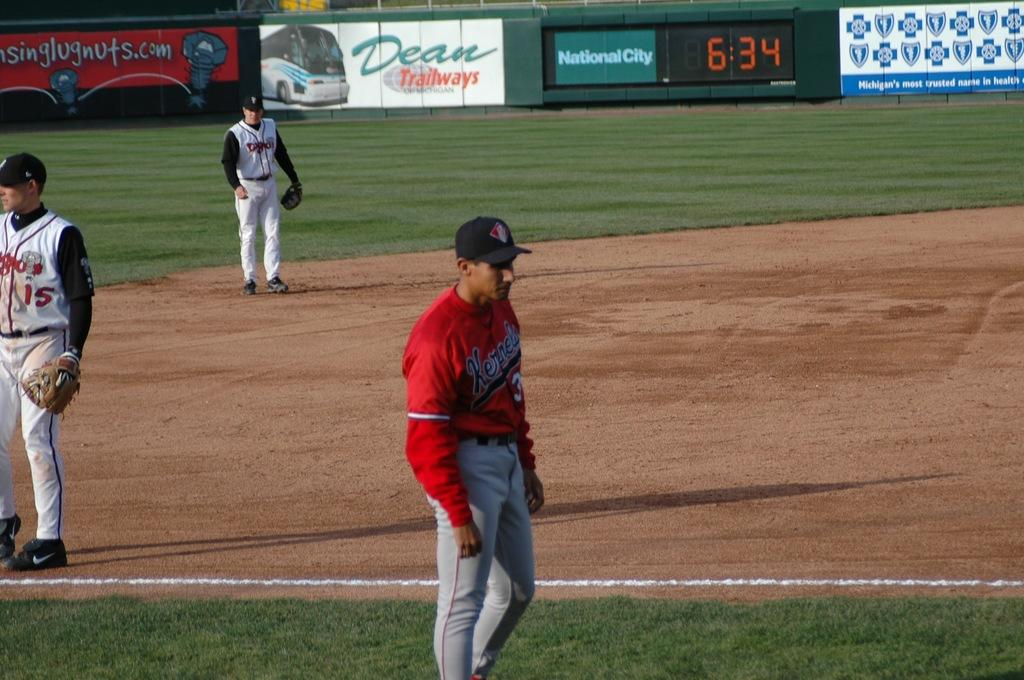<image>
Render a clear and concise summary of the photo. A baseball game takes place at 6:34 PM. 